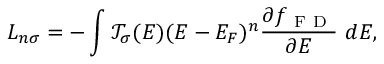Convert formula to latex. <formula><loc_0><loc_0><loc_500><loc_500>L _ { n \sigma } = - \int \mathcal { T } _ { \sigma } ( E ) ( E - E _ { F } ) ^ { n } \frac { \partial f _ { F D } } { \partial E } d E ,</formula> 